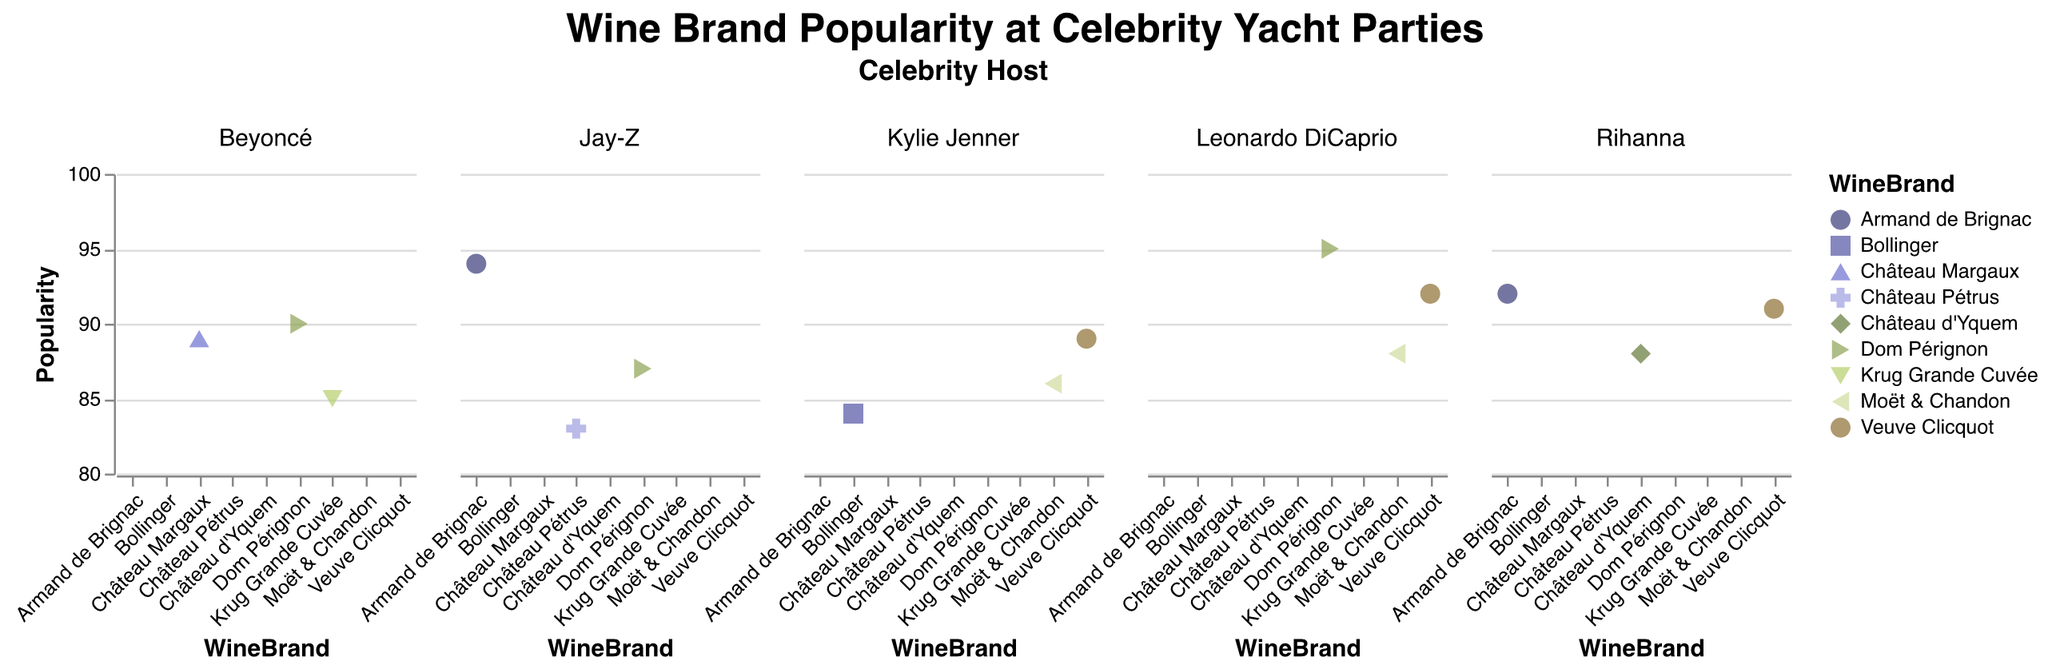How is the popularity of Veuve Clicquot distributed among different celebrity hosts? Veuve Clicquot has three data points, one each for Leonardo DiCaprio, Rihanna, and Kylie Jenner with popularity values of 92, 91, and 89 respectively.
Answer: 92 for Leonardo DiCaprio, 91 for Rihanna, 89 for Kylie Jenner What is the most popular wine brand served at Leonardo DiCaprio's parties? By comparing the popularity values of the wines served at Leonardo DiCaprio's parties, Dom Pérignon has the highest popularity at 95.
Answer: Dom Pérignon How does Jay-Z's highest rated wine compare to Beyoncé's highest rated wine? Jay-Z's highest rated wine is Armand de Brignac with a popularity of 94. Beyoncé's highest rated wine is Dom Pérignon with a popularity of 90. Comparing these, Jay-Z's highest rated wine has a higher popularity.
Answer: Jay-Z's wine (Armand de Brignac, 94) is more popular Which celebrity hosts have served Dom Pérignon, and how do the popularity scores compare? Leonardo DiCaprio, Beyoncé, and Jay-Z have all served Dom Pérignon. The popularity scores are 95 for Leonardo DiCaprio, 90 for Beyoncé, and 87 for Jay-Z.
Answer: Leonardo DiCaprio (95), Beyoncé (90), Jay-Z (87) Among the wines listed, which has the lowest popularity, and which celebrity host served it? The lowest popularity score is 83 for Château Pétrus served at Jay-Z's parties.
Answer: Château Pétrus served by Jay-Z Which wine brand served at Rihanna's parties has the highest popularity? By comparing the values for Rihanna's wines, Armand de Brignac has the highest popularity of 92.
Answer: Armand de Brignac How does the average popularity of wines served by Beyoncé compare to those served by Kylie Jenner? Calculate the averages: Beyoncé (90 + 89 + 85 = 264, 264/3 = 88), Kylie Jenner (86 + 89 + 84 = 259, 259/3 ≈ 86.33). Beyoncé's average popularity is 88, while Kylie Jenner's is approximately 86.33.
Answer: Beyoncé: 88, Kylie Jenner: 86.33 What is the overall popularity range (maximum - minimum popularity) of wines served by all celebrities? Identify the maximum and minimum popularity values from all data points. Maximum: Dom Pérignon (95 by Leonardo DiCaprio), Minimum: Château Pétrus (83 by Jay-Z). The range is 95 - 83 = 12.
Answer: 12 